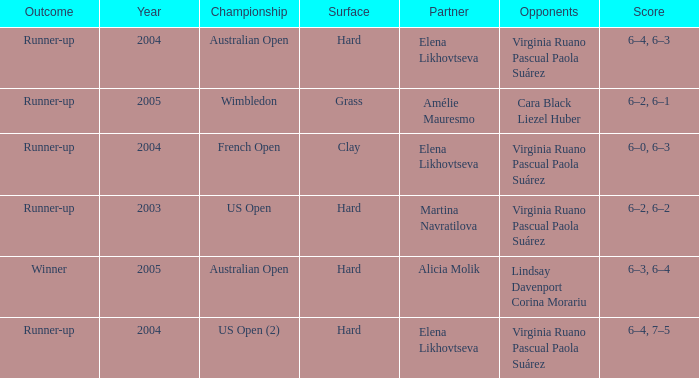When us open (2) is the championship what is the surface? Hard. 